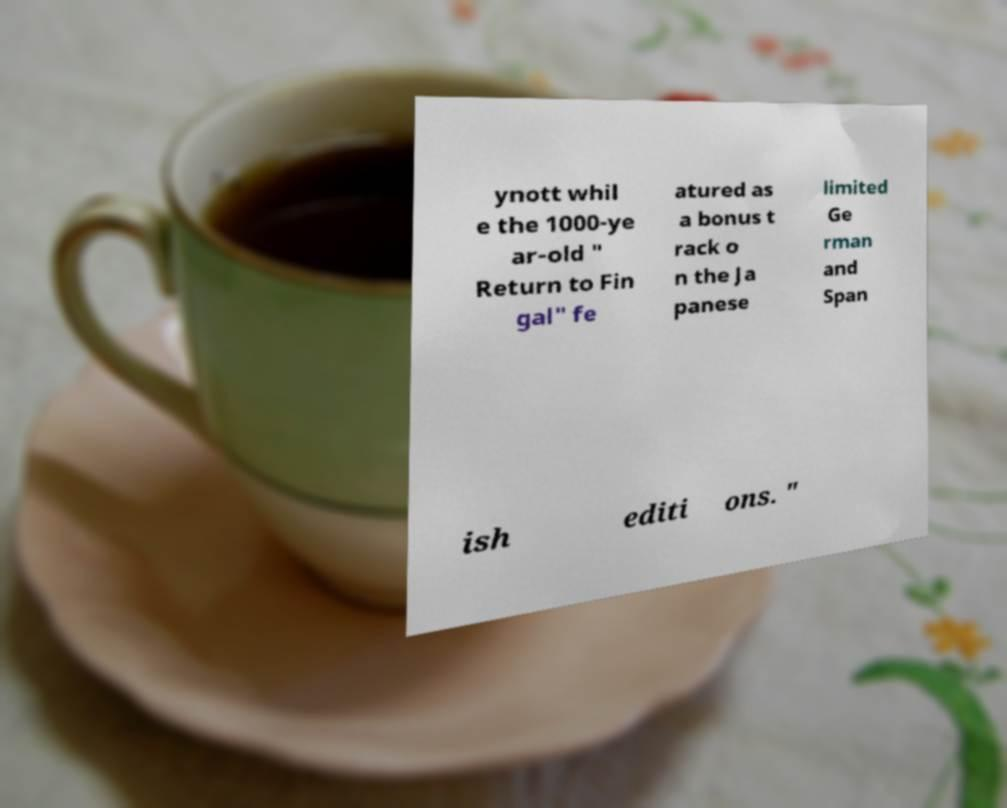Can you read and provide the text displayed in the image?This photo seems to have some interesting text. Can you extract and type it out for me? ynott whil e the 1000-ye ar-old " Return to Fin gal" fe atured as a bonus t rack o n the Ja panese limited Ge rman and Span ish editi ons. " 